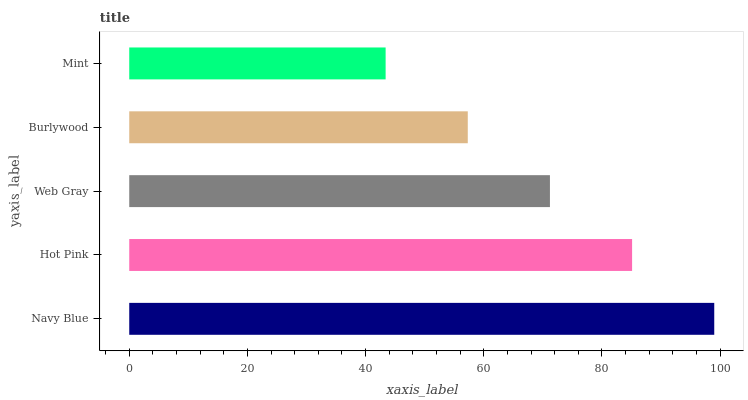Is Mint the minimum?
Answer yes or no. Yes. Is Navy Blue the maximum?
Answer yes or no. Yes. Is Hot Pink the minimum?
Answer yes or no. No. Is Hot Pink the maximum?
Answer yes or no. No. Is Navy Blue greater than Hot Pink?
Answer yes or no. Yes. Is Hot Pink less than Navy Blue?
Answer yes or no. Yes. Is Hot Pink greater than Navy Blue?
Answer yes or no. No. Is Navy Blue less than Hot Pink?
Answer yes or no. No. Is Web Gray the high median?
Answer yes or no. Yes. Is Web Gray the low median?
Answer yes or no. Yes. Is Hot Pink the high median?
Answer yes or no. No. Is Burlywood the low median?
Answer yes or no. No. 